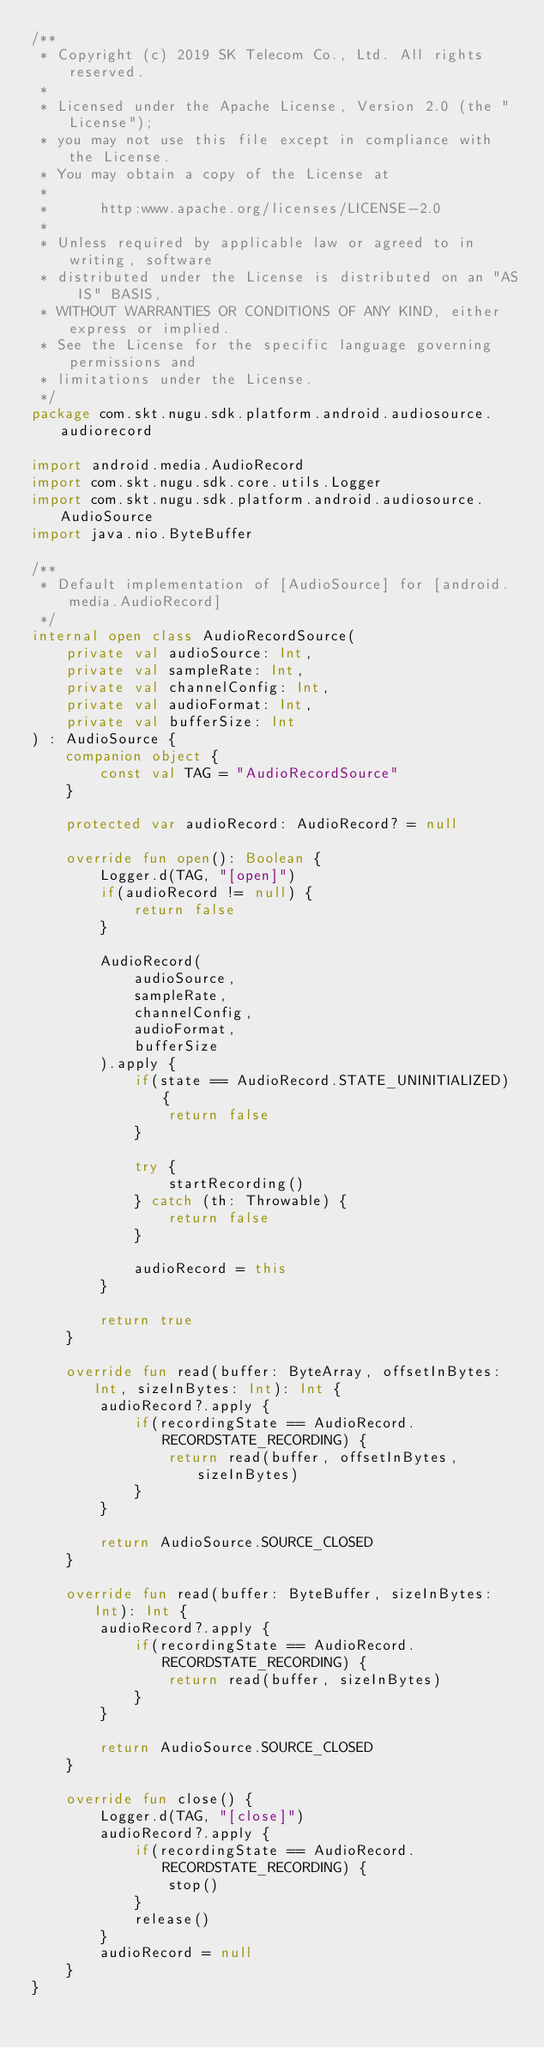<code> <loc_0><loc_0><loc_500><loc_500><_Kotlin_>/**
 * Copyright (c) 2019 SK Telecom Co., Ltd. All rights reserved.
 *
 * Licensed under the Apache License, Version 2.0 (the "License");
 * you may not use this file except in compliance with the License.
 * You may obtain a copy of the License at
 *
 *      http:www.apache.org/licenses/LICENSE-2.0
 *
 * Unless required by applicable law or agreed to in writing, software
 * distributed under the License is distributed on an "AS IS" BASIS,
 * WITHOUT WARRANTIES OR CONDITIONS OF ANY KIND, either express or implied.
 * See the License for the specific language governing permissions and
 * limitations under the License.
 */
package com.skt.nugu.sdk.platform.android.audiosource.audiorecord

import android.media.AudioRecord
import com.skt.nugu.sdk.core.utils.Logger
import com.skt.nugu.sdk.platform.android.audiosource.AudioSource
import java.nio.ByteBuffer

/**
 * Default implementation of [AudioSource] for [android.media.AudioRecord]
 */
internal open class AudioRecordSource(
    private val audioSource: Int,
    private val sampleRate: Int,
    private val channelConfig: Int,
    private val audioFormat: Int,
    private val bufferSize: Int
) : AudioSource {
    companion object {
        const val TAG = "AudioRecordSource"
    }

    protected var audioRecord: AudioRecord? = null

    override fun open(): Boolean {
        Logger.d(TAG, "[open]")
        if(audioRecord != null) {
            return false
        }

        AudioRecord(
            audioSource,
            sampleRate,
            channelConfig,
            audioFormat,
            bufferSize
        ).apply {
            if(state == AudioRecord.STATE_UNINITIALIZED) {
                return false
            }

            try {
                startRecording()
            } catch (th: Throwable) {
                return false
            }

            audioRecord = this
        }

        return true
    }

    override fun read(buffer: ByteArray, offsetInBytes: Int, sizeInBytes: Int): Int {
        audioRecord?.apply {
            if(recordingState == AudioRecord.RECORDSTATE_RECORDING) {
                return read(buffer, offsetInBytes, sizeInBytes)
            }
        }

        return AudioSource.SOURCE_CLOSED
    }

    override fun read(buffer: ByteBuffer, sizeInBytes: Int): Int {
        audioRecord?.apply {
            if(recordingState == AudioRecord.RECORDSTATE_RECORDING) {
                return read(buffer, sizeInBytes)
            }
        }

        return AudioSource.SOURCE_CLOSED
    }

    override fun close() {
        Logger.d(TAG, "[close]")
        audioRecord?.apply {
            if(recordingState == AudioRecord.RECORDSTATE_RECORDING) {
                stop()
            }
            release()
        }
        audioRecord = null
    }
}</code> 